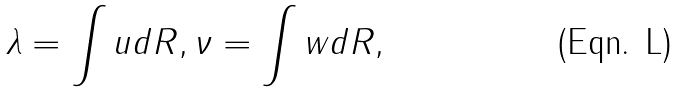Convert formula to latex. <formula><loc_0><loc_0><loc_500><loc_500>\lambda = \int u d R , \nu = \int w d R ,</formula> 